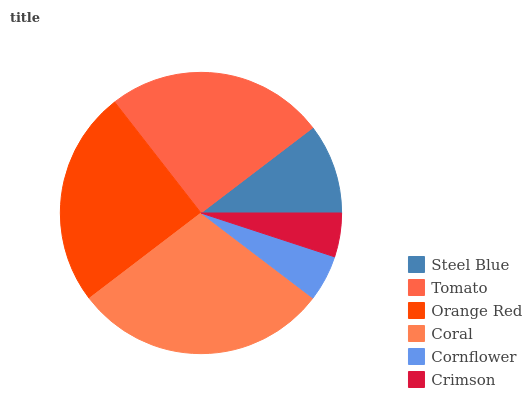Is Crimson the minimum?
Answer yes or no. Yes. Is Coral the maximum?
Answer yes or no. Yes. Is Tomato the minimum?
Answer yes or no. No. Is Tomato the maximum?
Answer yes or no. No. Is Tomato greater than Steel Blue?
Answer yes or no. Yes. Is Steel Blue less than Tomato?
Answer yes or no. Yes. Is Steel Blue greater than Tomato?
Answer yes or no. No. Is Tomato less than Steel Blue?
Answer yes or no. No. Is Orange Red the high median?
Answer yes or no. Yes. Is Steel Blue the low median?
Answer yes or no. Yes. Is Steel Blue the high median?
Answer yes or no. No. Is Coral the low median?
Answer yes or no. No. 